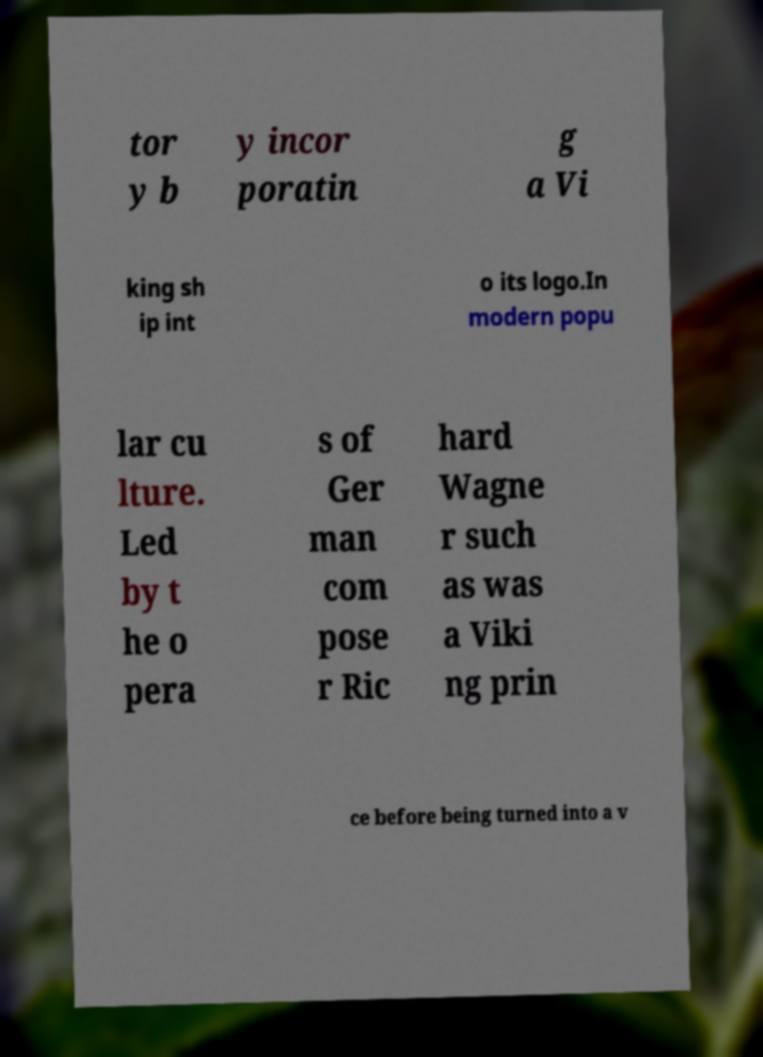Could you assist in decoding the text presented in this image and type it out clearly? tor y b y incor poratin g a Vi king sh ip int o its logo.In modern popu lar cu lture. Led by t he o pera s of Ger man com pose r Ric hard Wagne r such as was a Viki ng prin ce before being turned into a v 